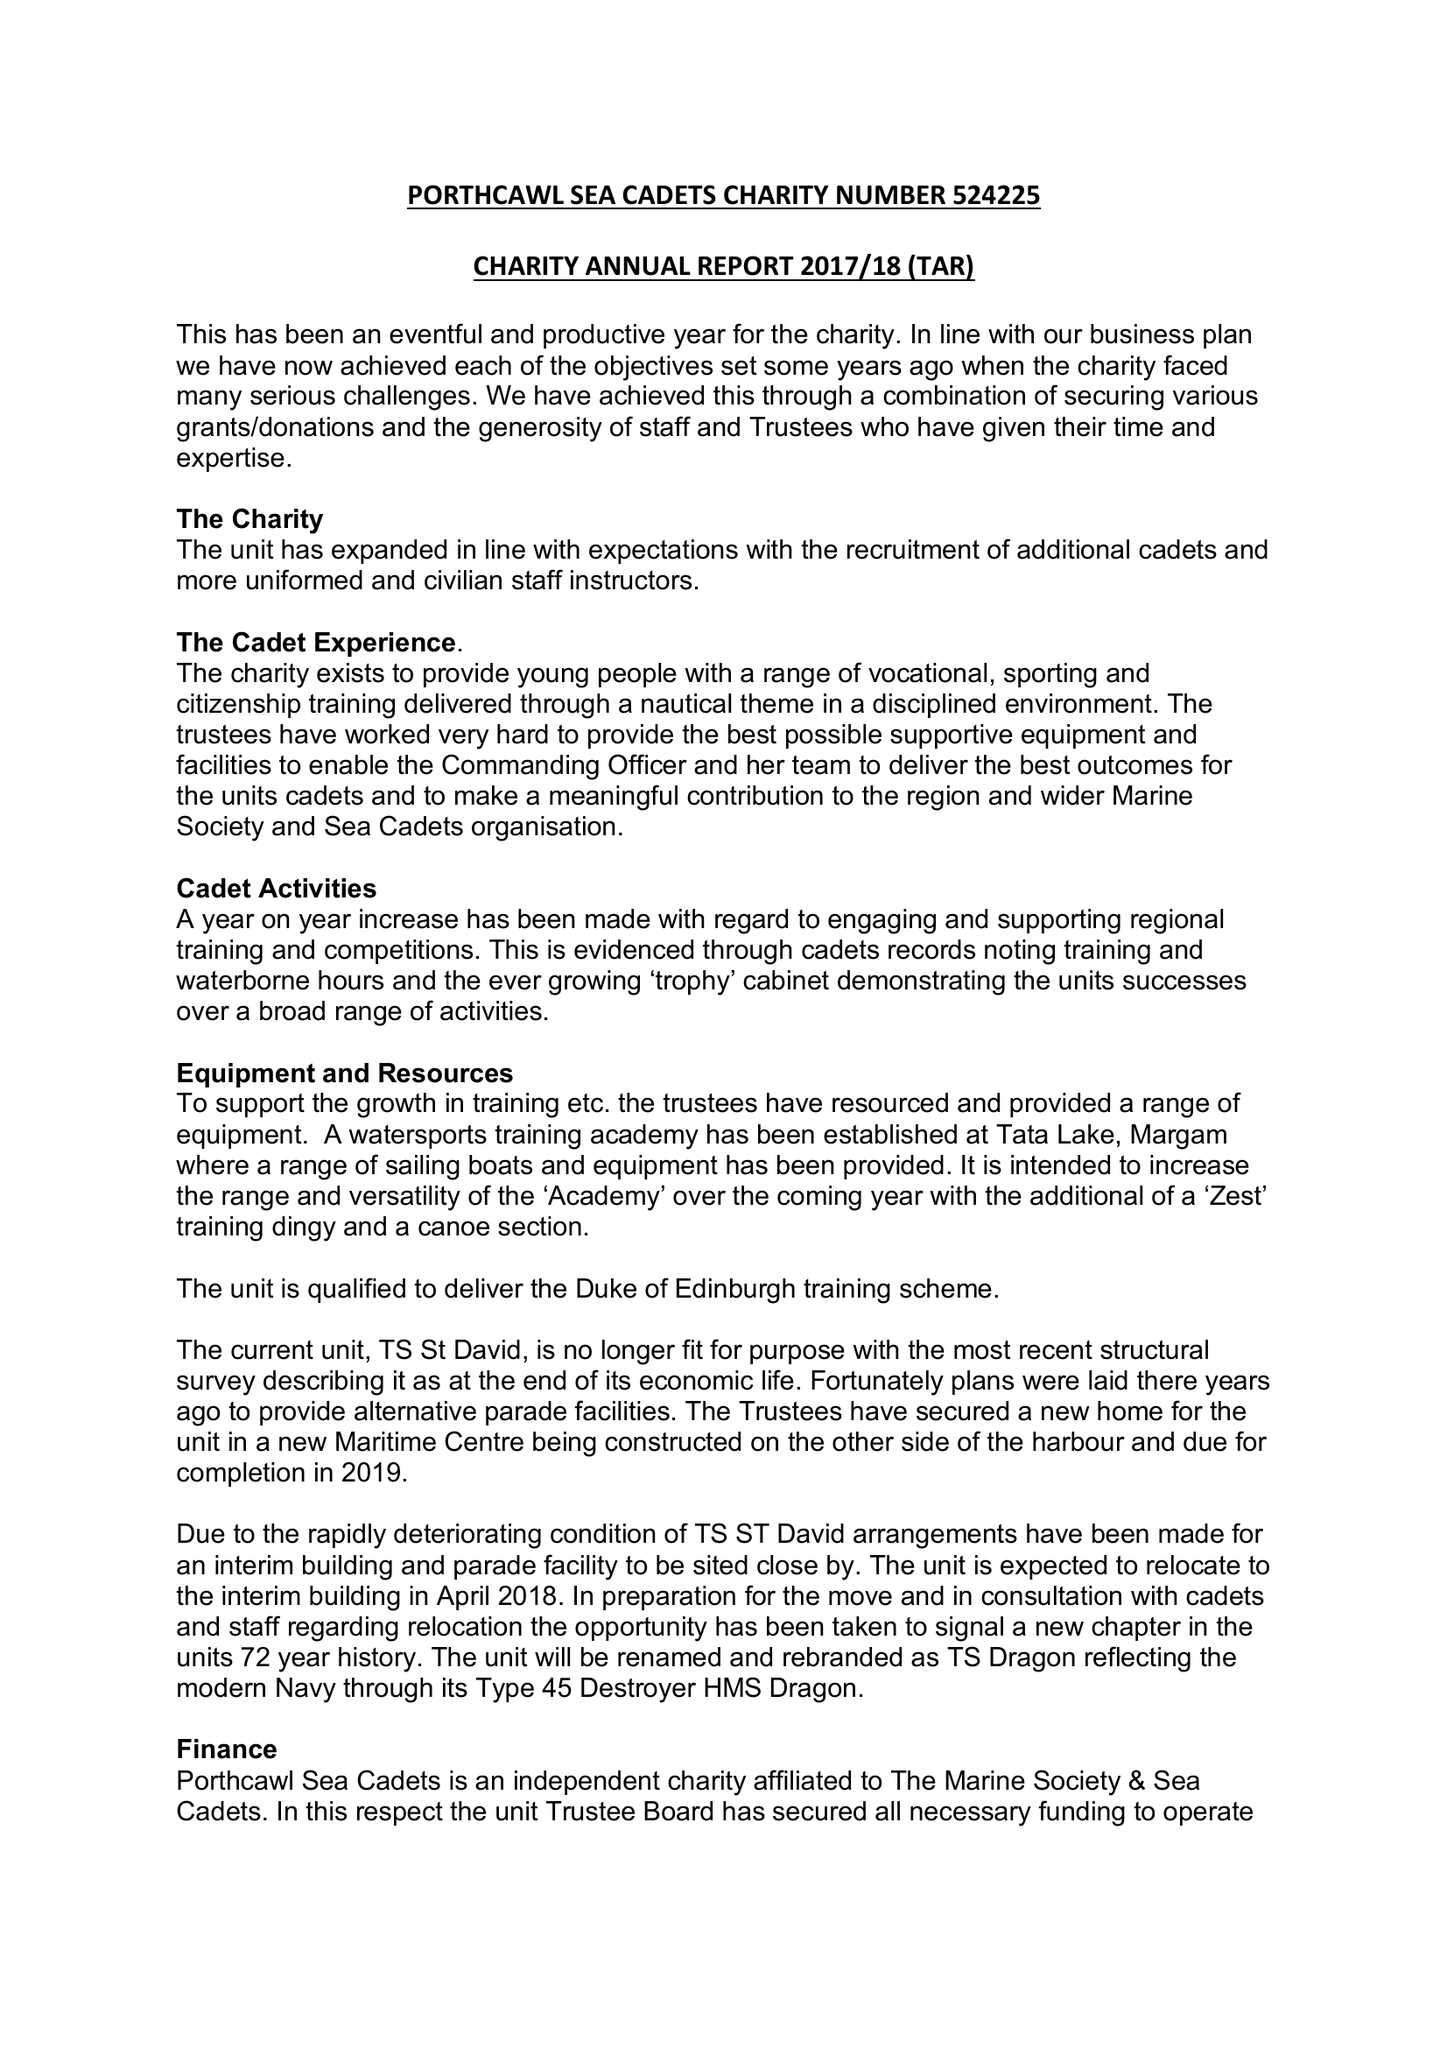What is the value for the charity_name?
Answer the question using a single word or phrase. Porthcawl 